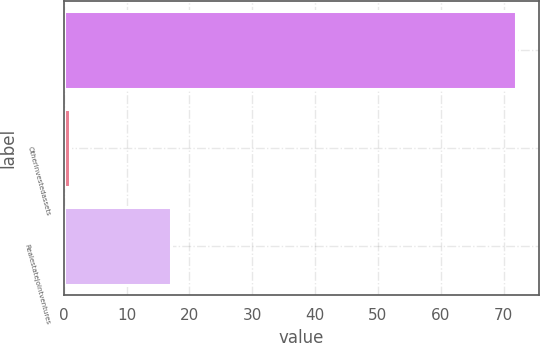Convert chart to OTSL. <chart><loc_0><loc_0><loc_500><loc_500><bar_chart><ecel><fcel>Otherinvestedassets<fcel>Realestatejointventures<nl><fcel>72<fcel>1<fcel>17<nl></chart> 